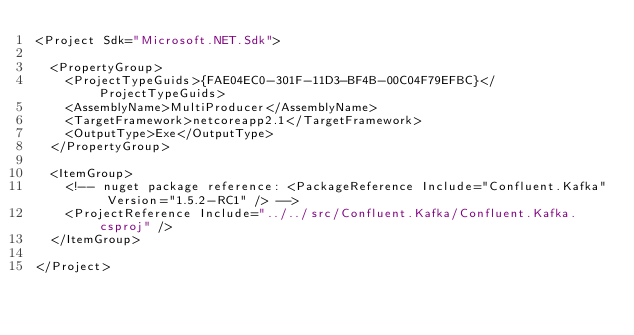<code> <loc_0><loc_0><loc_500><loc_500><_XML_><Project Sdk="Microsoft.NET.Sdk">

  <PropertyGroup>
    <ProjectTypeGuids>{FAE04EC0-301F-11D3-BF4B-00C04F79EFBC}</ProjectTypeGuids>
    <AssemblyName>MultiProducer</AssemblyName>
    <TargetFramework>netcoreapp2.1</TargetFramework>
    <OutputType>Exe</OutputType>
  </PropertyGroup>

  <ItemGroup>
    <!-- nuget package reference: <PackageReference Include="Confluent.Kafka" Version="1.5.2-RC1" /> -->
    <ProjectReference Include="../../src/Confluent.Kafka/Confluent.Kafka.csproj" />
  </ItemGroup>

</Project>
</code> 